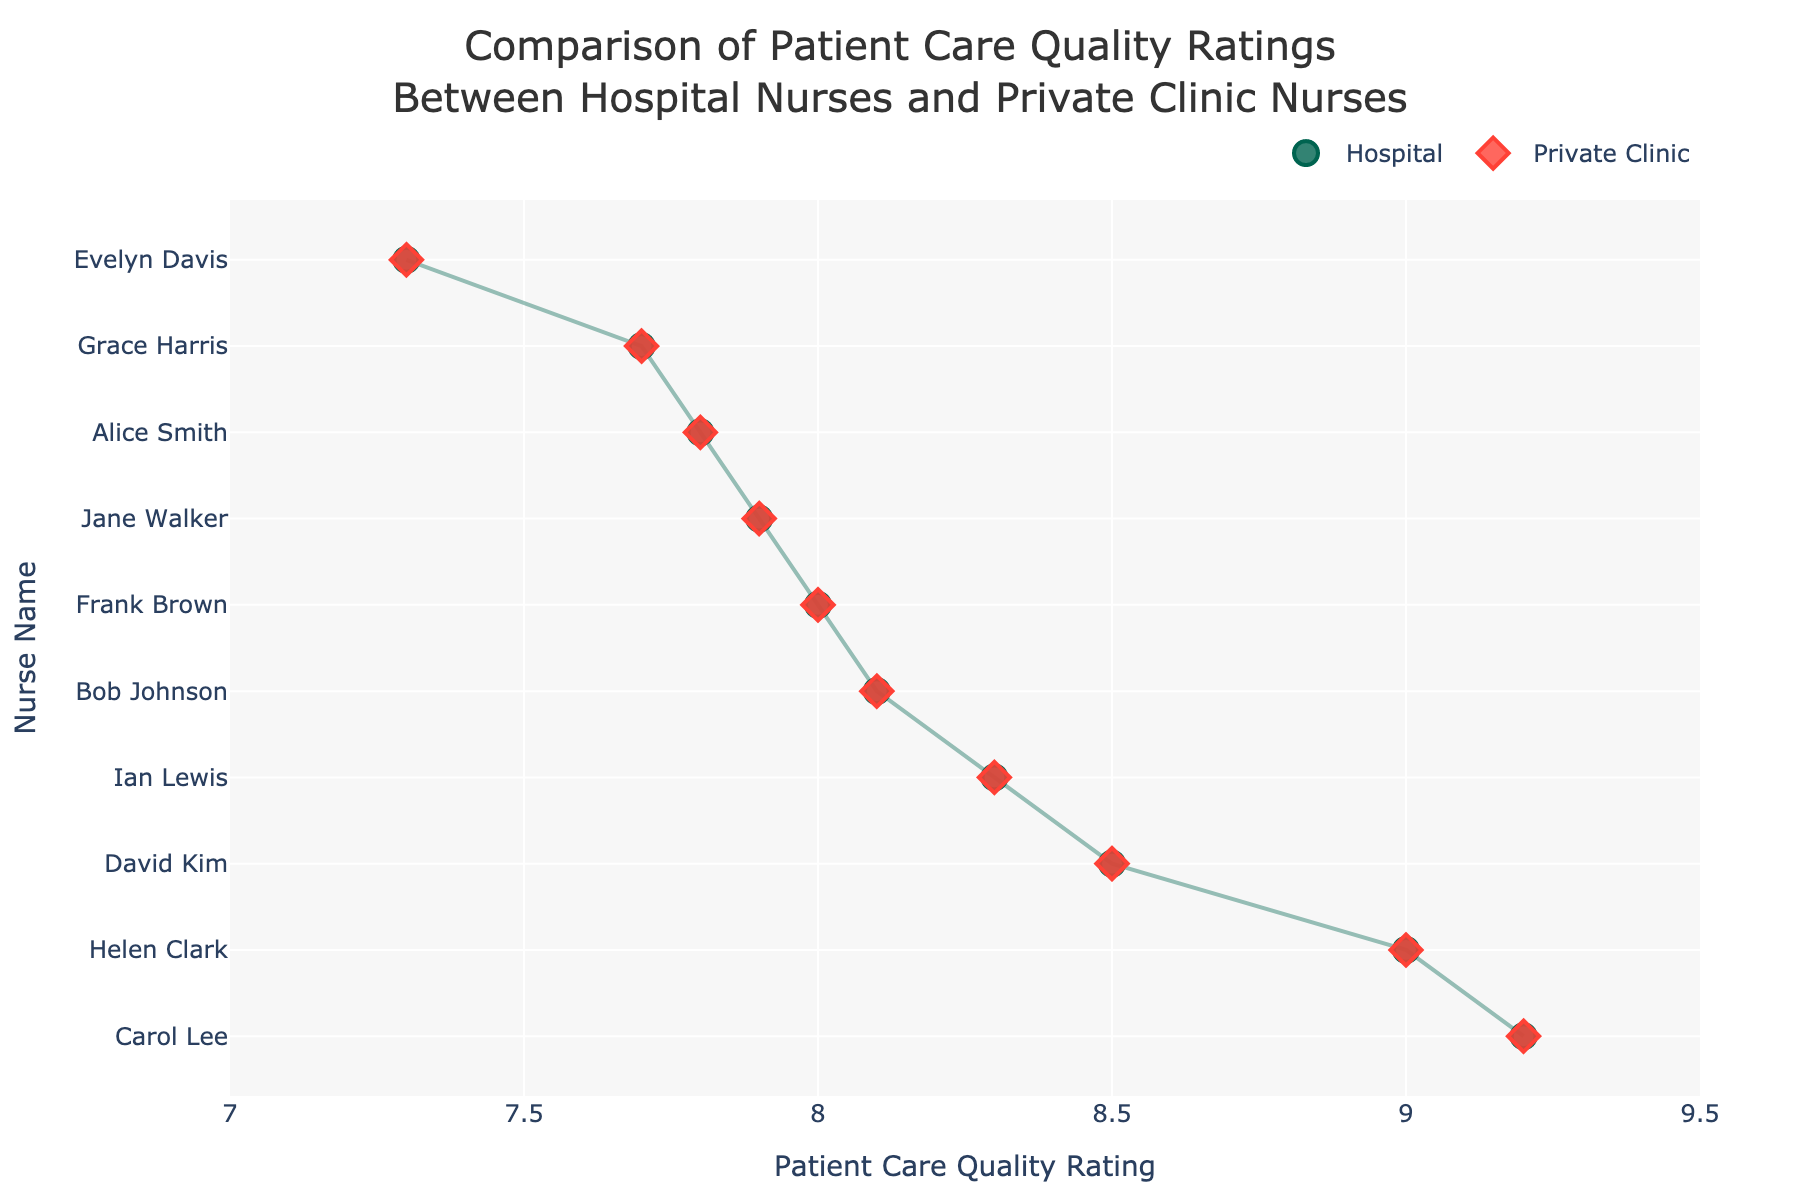What is the title of the plot? The title of the plot is usually located at the top center of the figure. By looking at the visual, one can see the main text.
Answer: Comparison of Patient Care Quality Ratings Between Hospital Nurses and Private Clinic Nurses Who has the highest Patient Care Quality Rating? By checking the highest point on the x-axis and identifying the corresponding nurse's name on the y-axis, you can determine which nurse has the highest rating.
Answer: Carol Lee What is the Patient Care Quality Rating for Jane Walker? Find Jane Walker on the y-axis and trace horizontally to her corresponding rating on the x-axis.
Answer: 7.9 Which location has the most nurses listed in the plot? Count the number of nurses per location and identify which location appears most frequently in the figure.
Answer: Chennai Is the rating for hospital nurses generally higher or lower compared to private clinic nurses? Compare the positions of the hospital markers (circles) with the private clinic markers (diamonds) along the x-axis for each nurse and assess overall trends.
Answer: Generally higher What are the Patient Care Quality Ratings for Helen Clark from both hospital and private clinic? Locate Helen Clark on the y-axis and find the ratings for both the circle (hospital) and diamond (private clinic) markers aligned horizontally.
Answer: 9.0 for both Who has the lowest Patient Care Quality Rating? By checking the lowest point on the x-axis and identifying the corresponding nurse's name on the y-axis, you can determine which nurse has the lowest rating.
Answer: Evelyn Davis How many nurses have a Patient Care Quality Rating of 8.0 or higher? Count the number of nurses whose corresponding x-axis values are 8.0 or greater.
Answer: 7 nurses What is the average Patient Care Quality Rating for nurses from Chennai? Identify the nurses from Chennai, find their ratings, sum them, and then divide by the count of those nurses. 7.8 (Alice Smith) + 8.1 (Bob Johnson) gives a total of 15.9, and there are 2 nurses from Chennai, so the average is 15.9 / 2.
Answer: 7.95 Between Riverside Regional Hospital and Evergreen Clinic, which has the higher rating? Compare the hospital (circle) and private clinic (diamond) ratings for Ian Lewis, corresponding to Riverside Regional Hospital and Evergreen Clinic, respectively.
Answer: Evergreen Clinic 